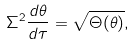Convert formula to latex. <formula><loc_0><loc_0><loc_500><loc_500>\Sigma ^ { 2 } \frac { d \theta } { d \tau } = \sqrt { \Theta ( \theta ) } ,</formula> 